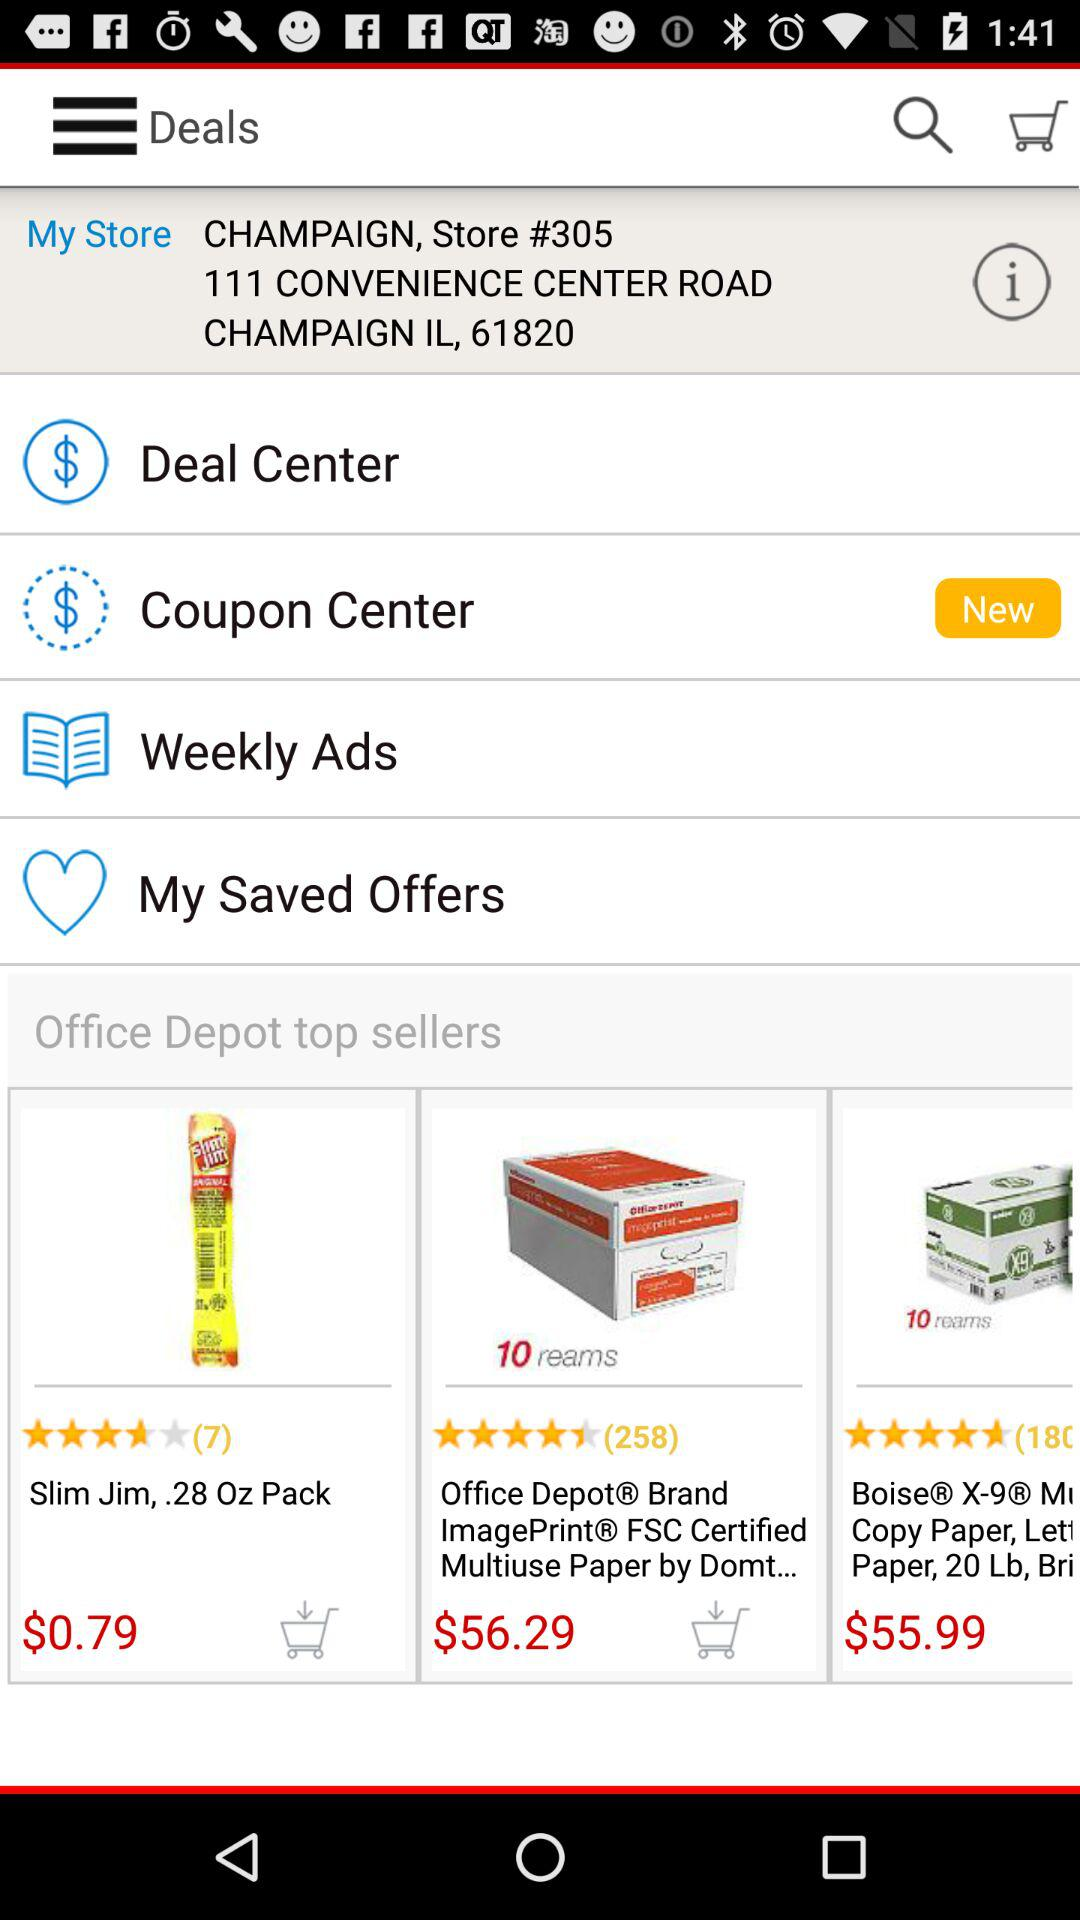How many reviews did Slim Jim, 28 Oz Pack get? Slim Jim, 28 Oz Pack got 7 reviews. 